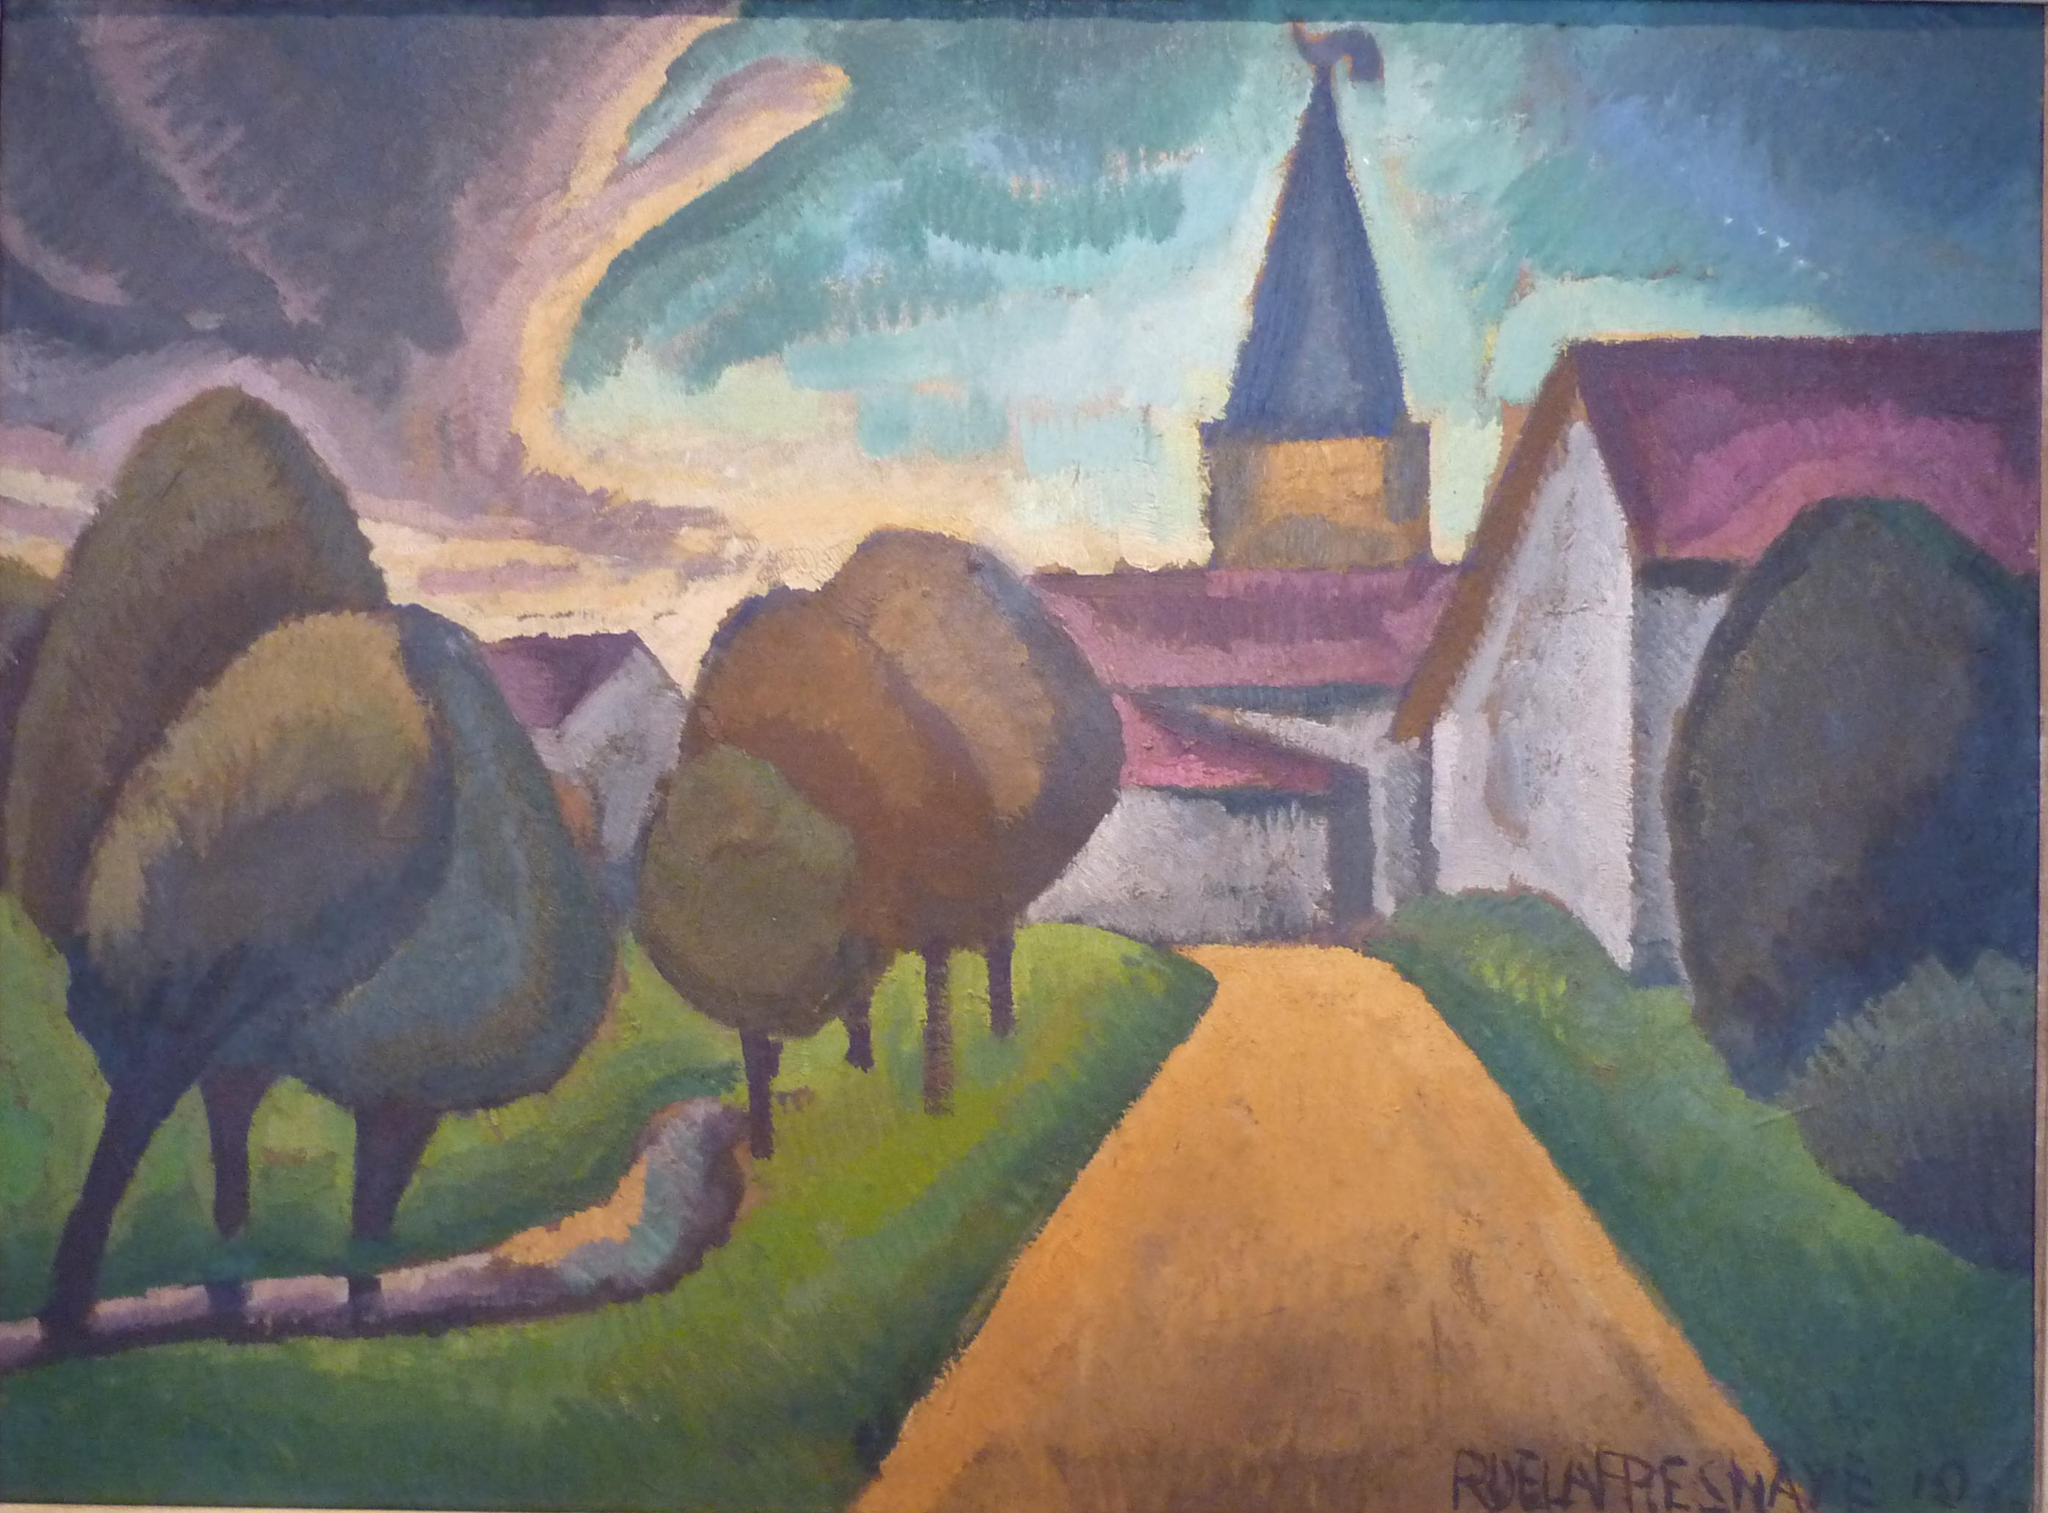How do you think the artist felt while creating this piece? The artist likely felt a deep sense of connection to nature and nostalgia while creating this piece. The harmonious blend of colors and the serene landscape suggest a meditative and introspective mindset. The attention to detail in the winding road and the quaint village hints at a longing to capture the tranquility and simplicity of rural life. The bold brushstrokes and vibrant palette reflect a passionate engagement with the canvas, showcasing the artist's desire to immortalize the serene beauty of the countryside. As the church spire reaches skyward, it indicates a spiritual inspiration guiding the artist's hand, imbuing the scene with a sense of reverence and peace. What would happen if the colors in this painting suddenly started changing every second? If the colors in this painting began to change every second, it would transform into a mesmerizing, dynamic landscape, continuously evolving before the viewer's eyes. The scene would feel alive, with the vibrant colors morphing to reflect different times of day and seasons – morning light transforming to dusk, summer greenery melting into autumnal oranges and browns, and the tranquil blue sky shifting to the deep purples of twilight. This constant change would create a sense of fluidity and movement, as though the painting were breathing. The village might glow in different lighting, highlighting various aspects of its architecture and charm. This dynamic transformation would evoke different emotions and interpretations with each passing second, making the painting an ever-changing source of inspiration and wonder. 